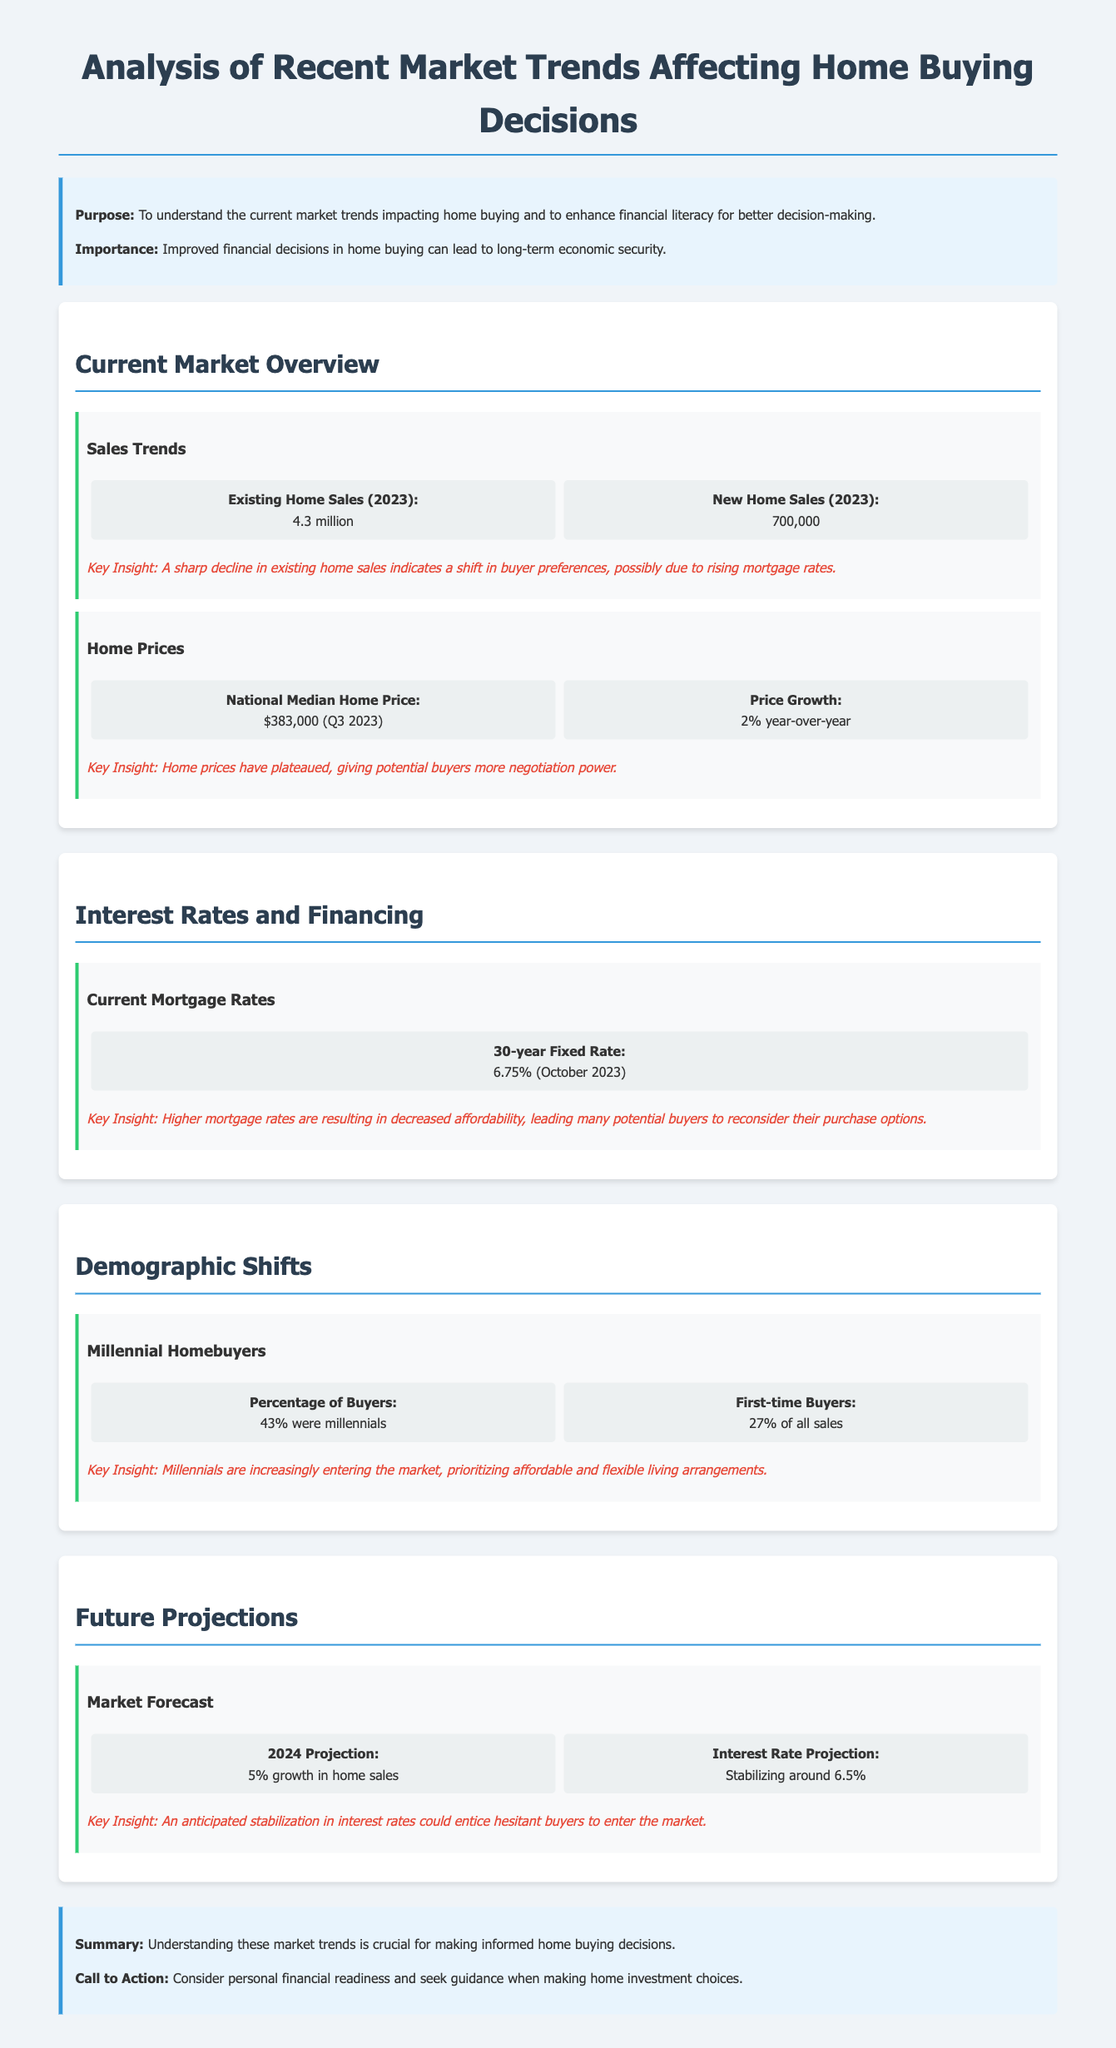what is the national median home price as of Q3 2023? The national median home price is stated in the document under the Home Prices section as $383,000.
Answer: $383,000 how many existing home sales were recorded in 2023? The document lists the figure for existing home sales in 2023 under the Sales Trends section, which is 4.3 million.
Answer: 4.3 million what percentage of homebuyers were millennials? The document specifies that 43% of homebuyers were millennials in the Demographic Shifts section.
Answer: 43% what is the projected growth in home sales for 2024? The document mentions a 5% growth in home sales as the projection for 2024 in the Future Projections section.
Answer: 5% what was the 30-year fixed mortgage rate as of October 2023? The document states the current mortgage rate as 6.75% in the Interest Rates and Financing section.
Answer: 6.75% what insight is gained from the decrease in existing home sales? The document suggests that a sharp decline in existing home sales indicates a shift in buyer preferences due to rising mortgage rates.
Answer: Shift in buyer preferences what is the percentage of first-time buyers among all sales? The document notes that 27% of all sales were made by first-time buyers, which is included in the Demographic Shifts section.
Answer: 27% what is the call to action mentioned in the conclusion? The call to action encourages considering personal financial readiness and seeking guidance for home investment choices, as stated in the conclusion.
Answer: Seek guidance what is the anticipated interest rate stabilization for 2024? The document projects that interest rates will stabilize around 6.5%, as mentioned in the Future Projections section.
Answer: 6.5% 